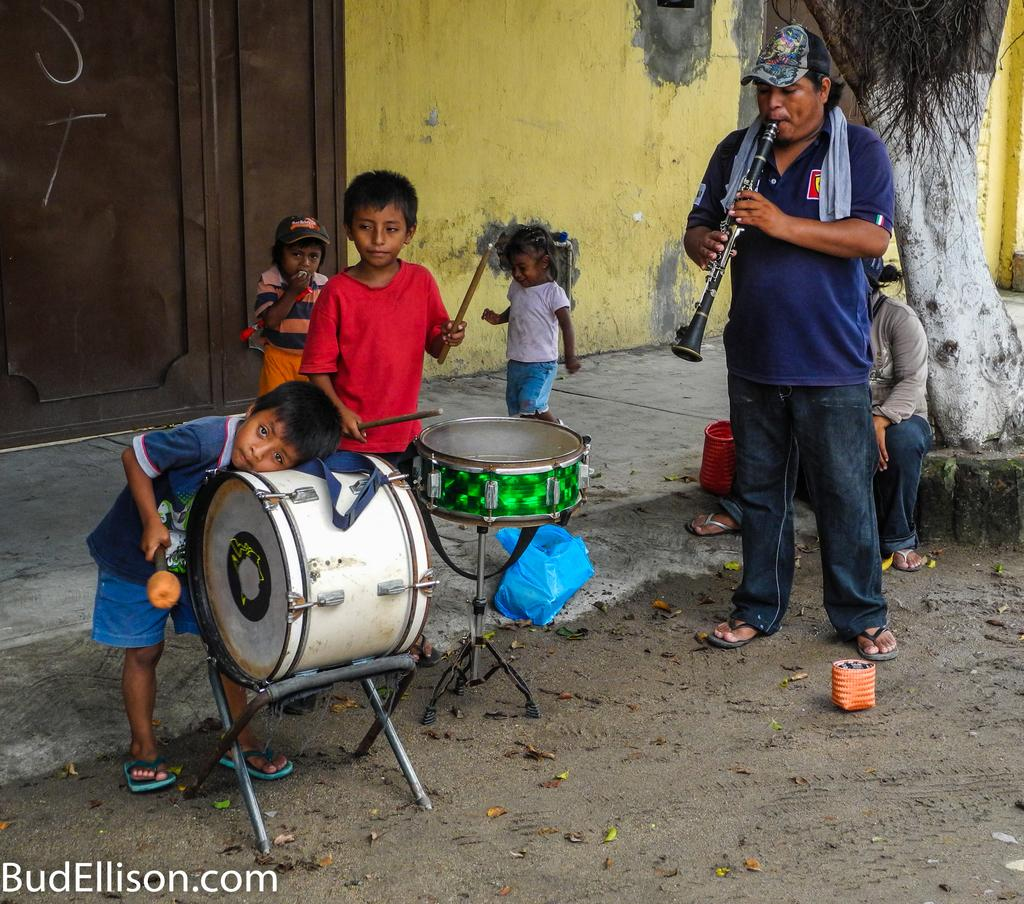What is the person in the image doing? The person is playing an oboe. What is the person wearing in the image? The person is wearing a blue shirt. What can be seen near the person playing the oboe? There are two kids near the drums. How many kids are visible in the image? There are four kids in total, with two near the drums and two behind them. What type of crayon is the person using to draw on the rail in the image? There is no crayon or rail present in the image. How does the person answer the question about the oboe in the image? The image does not depict a question being asked or answered about the oboe. 